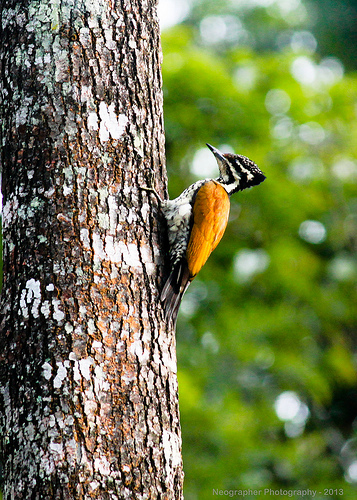Please provide the bounding box coordinate of the region this sentence describes: the leg of a bird. [0.44, 0.37, 0.47, 0.42] Please provide a short description for this region: [0.47, 0.38, 0.52, 0.45]. The feathers of a bird. Please provide the bounding box coordinate of the region this sentence describes: white spot on tree bark. [0.22, 0.72, 0.25, 0.76] Please provide the bounding box coordinate of the region this sentence describes: the tail feathers of a bird. [0.46, 0.5, 0.54, 0.62] Please provide a short description for this region: [0.21, 0.38, 0.48, 0.94]. The tree stem has some growimng orange plants. Please provide the bounding box coordinate of the region this sentence describes: the stripes of a bird. [0.58, 0.33, 0.64, 0.38] Please provide a short description for this region: [0.46, 0.37, 0.54, 0.49]. The inside feathers are white in color. 